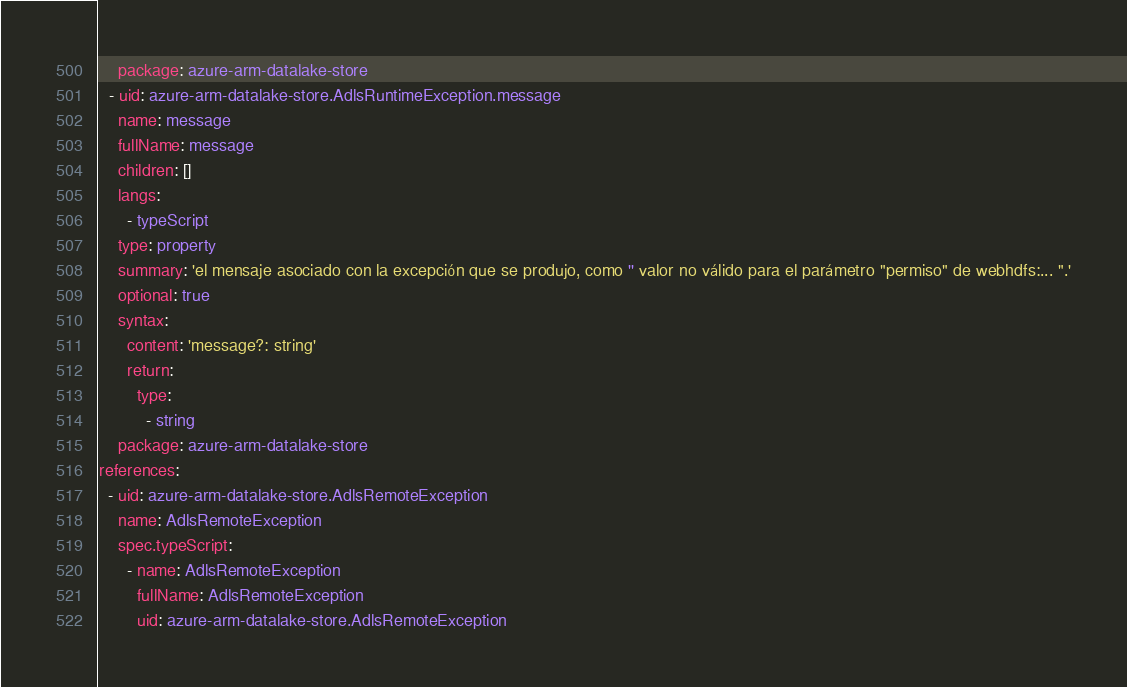<code> <loc_0><loc_0><loc_500><loc_500><_YAML_>    package: azure-arm-datalake-store
  - uid: azure-arm-datalake-store.AdlsRuntimeException.message
    name: message
    fullName: message
    children: []
    langs:
      - typeScript
    type: property
    summary: 'el mensaje asociado con la excepción que se produjo, como '' valor no válido para el parámetro "permiso" de webhdfs:... ".'
    optional: true
    syntax:
      content: 'message?: string'
      return:
        type:
          - string
    package: azure-arm-datalake-store
references:
  - uid: azure-arm-datalake-store.AdlsRemoteException
    name: AdlsRemoteException
    spec.typeScript:
      - name: AdlsRemoteException
        fullName: AdlsRemoteException
        uid: azure-arm-datalake-store.AdlsRemoteException</code> 